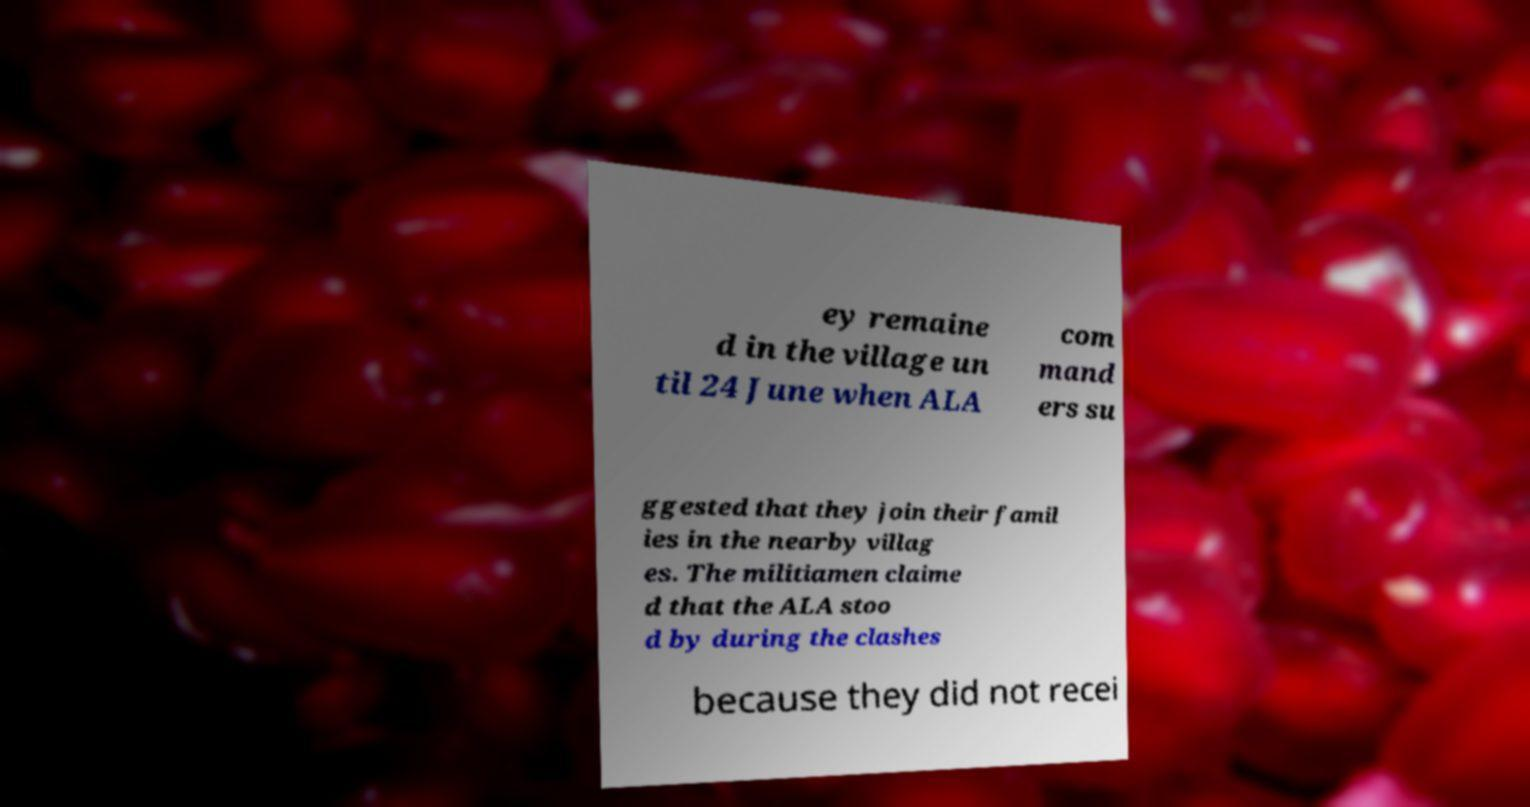Can you accurately transcribe the text from the provided image for me? ey remaine d in the village un til 24 June when ALA com mand ers su ggested that they join their famil ies in the nearby villag es. The militiamen claime d that the ALA stoo d by during the clashes because they did not recei 